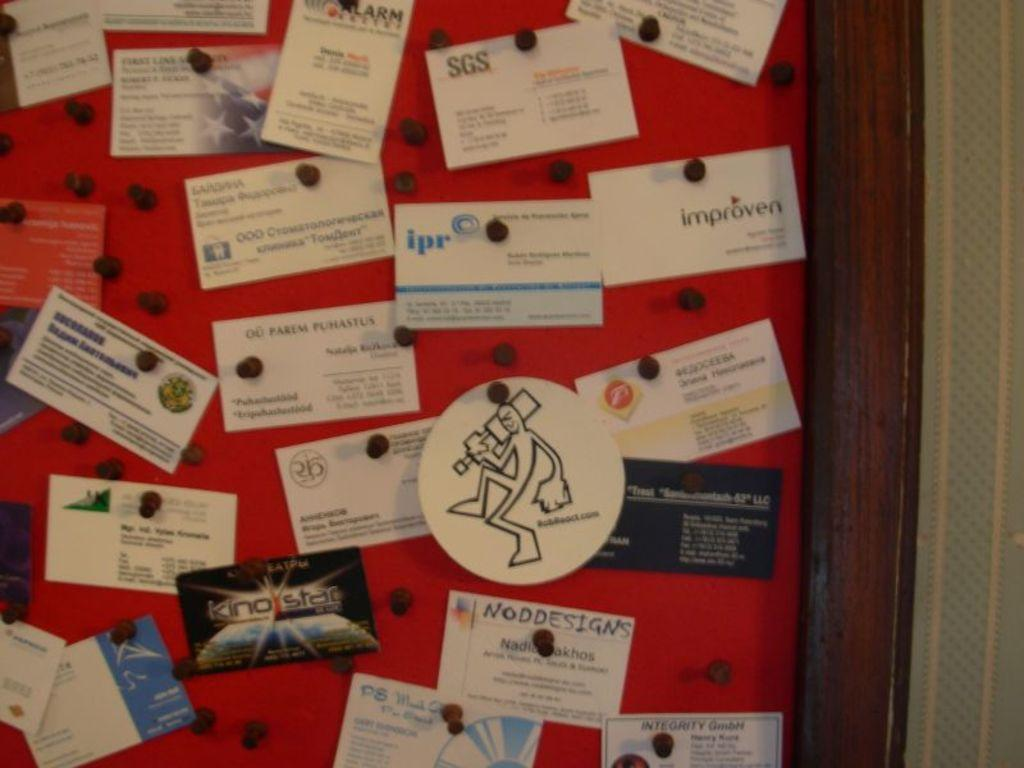<image>
Summarize the visual content of the image. Many business cards are pinned to a board, including one for ipr. 